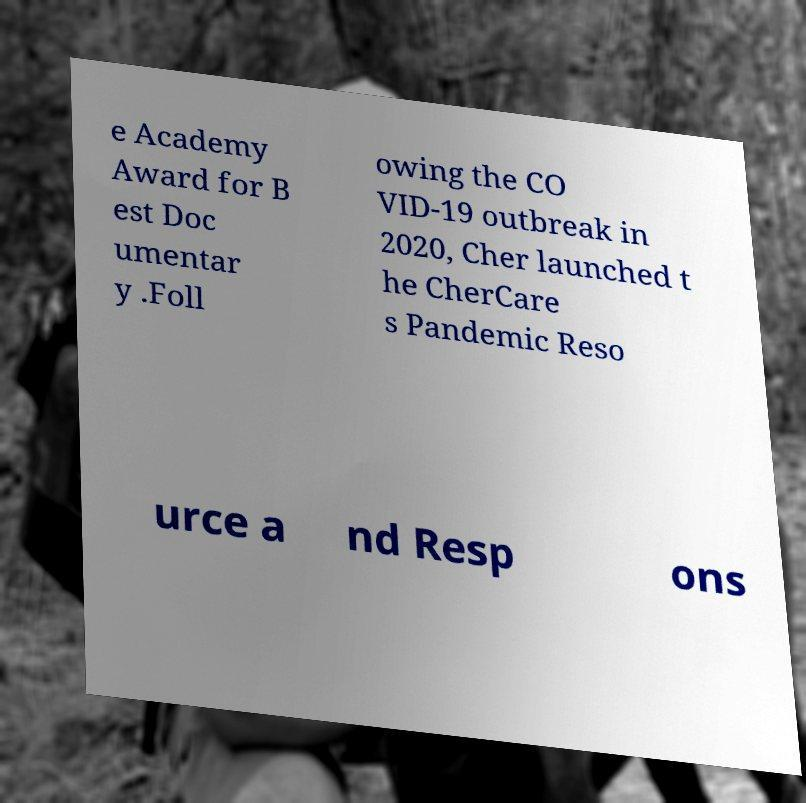Could you extract and type out the text from this image? e Academy Award for B est Doc umentar y .Foll owing the CO VID-19 outbreak in 2020, Cher launched t he CherCare s Pandemic Reso urce a nd Resp ons 